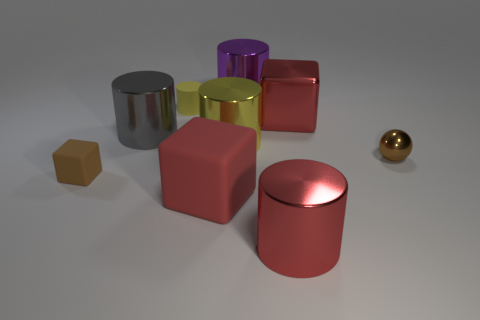Subtract all tiny cylinders. How many cylinders are left? 4 Subtract all yellow cylinders. Subtract all yellow blocks. How many cylinders are left? 3 Add 1 tiny matte things. How many objects exist? 10 Subtract all blocks. How many objects are left? 6 Subtract 0 gray spheres. How many objects are left? 9 Subtract all green matte objects. Subtract all red metal cylinders. How many objects are left? 8 Add 3 large red rubber blocks. How many large red rubber blocks are left? 4 Add 5 big cyan matte cubes. How many big cyan matte cubes exist? 5 